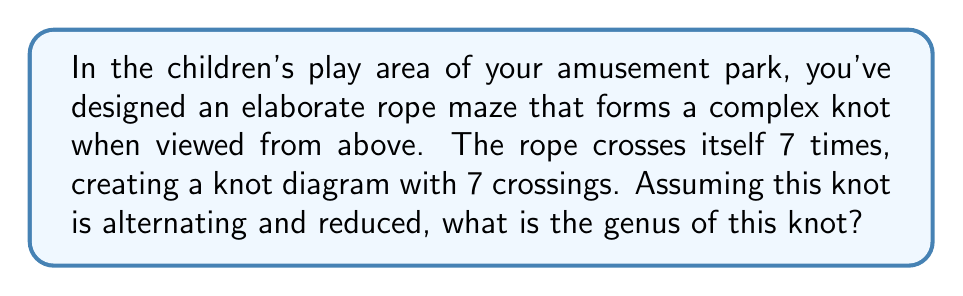Solve this math problem. To determine the genus of a knot, we can use the following steps:

1. First, recall that for an alternating, reduced knot diagram with $n$ crossings, the genus $g$ of the knot is given by the formula:

   $$g = \frac{1}{2}(n - s + 1)$$

   where $n$ is the number of crossings and $s$ is the number of Seifert circles.

2. We are given that $n = 7$ crossings.

3. To find $s$, we need to determine the number of Seifert circles. For an alternating knot, the number of Seifert circles is equal to the number of regions in the knot diagram minus 1.

4. The number of regions in a knot diagram is given by the formula:

   $$r = n + 2$$

   where $r$ is the number of regions and $n$ is the number of crossings.

5. Substituting $n = 7$:

   $$r = 7 + 2 = 9$$

6. Therefore, the number of Seifert circles $s$ is:

   $$s = r - 1 = 9 - 1 = 8$$

7. Now we can substitute these values into our genus formula:

   $$g = \frac{1}{2}(n - s + 1)$$
   $$g = \frac{1}{2}(7 - 8 + 1)$$
   $$g = \frac{1}{2}(0) = 0$$

Thus, the genus of this knot is 0.
Answer: 0 